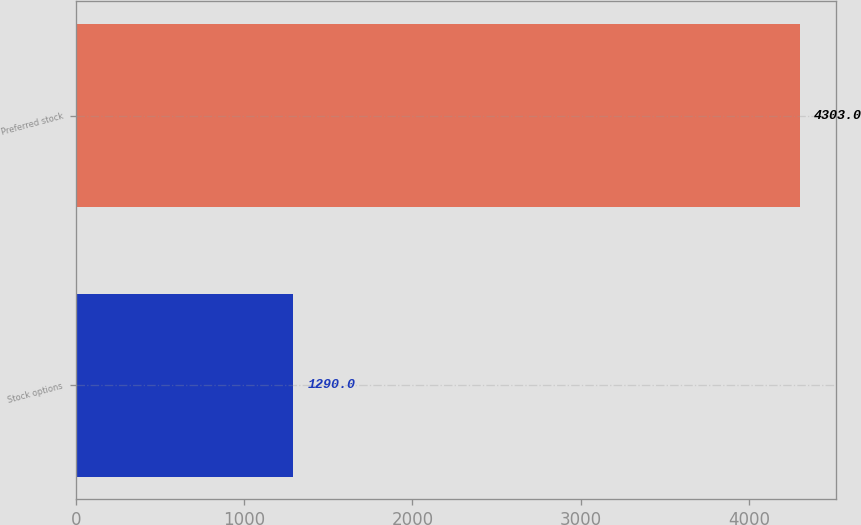<chart> <loc_0><loc_0><loc_500><loc_500><bar_chart><fcel>Stock options<fcel>Preferred stock<nl><fcel>1290<fcel>4303<nl></chart> 